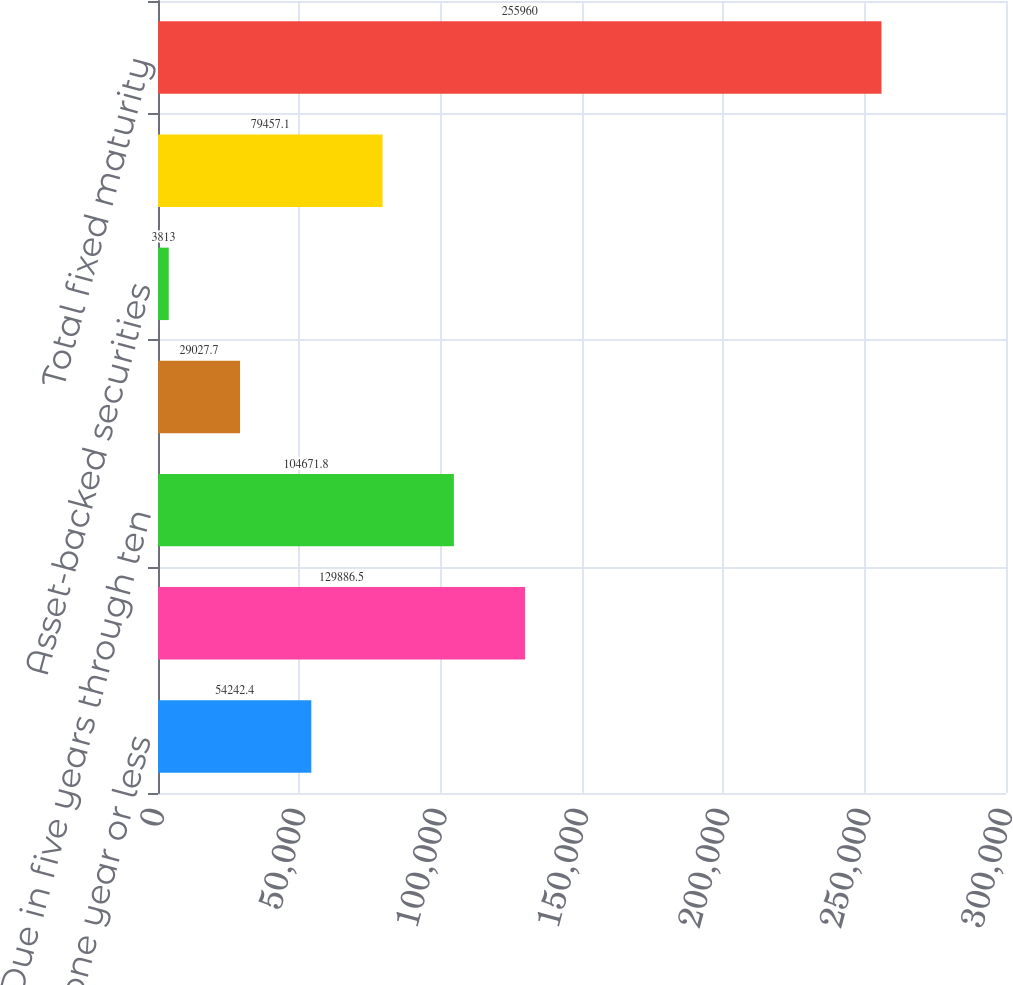<chart> <loc_0><loc_0><loc_500><loc_500><bar_chart><fcel>Due in one year or less<fcel>Due in one year through five<fcel>Due in five years through ten<fcel>Due after ten years<fcel>Asset-backed securities<fcel>Mortgage-backed securities<fcel>Total fixed maturity<nl><fcel>54242.4<fcel>129886<fcel>104672<fcel>29027.7<fcel>3813<fcel>79457.1<fcel>255960<nl></chart> 